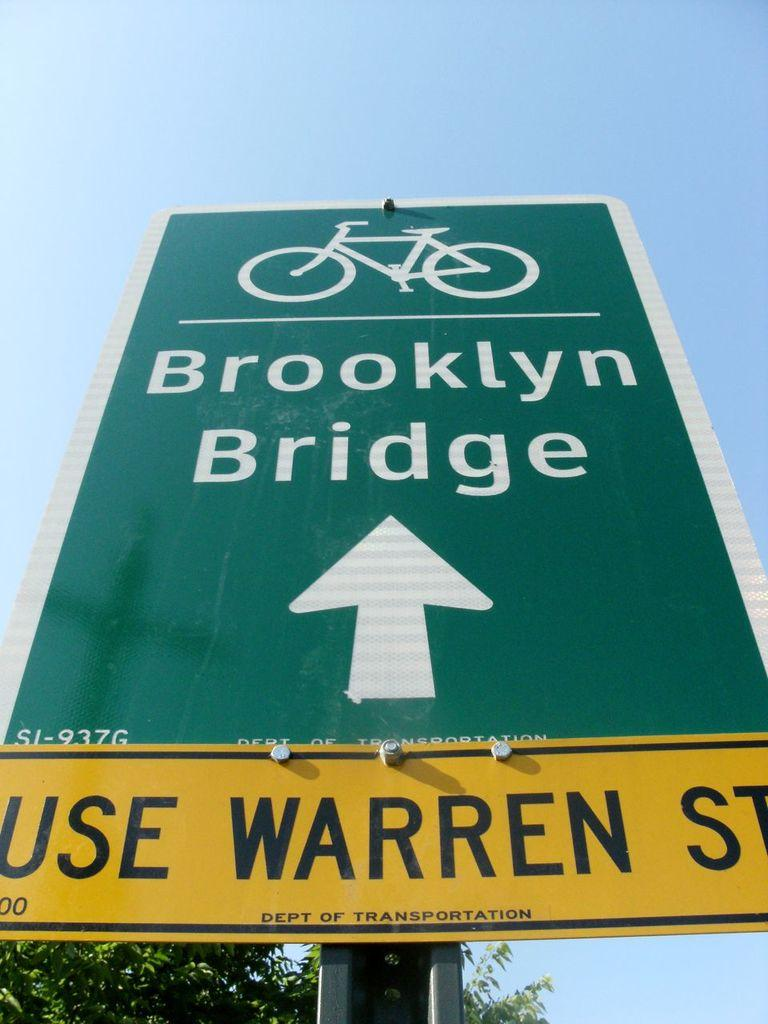<image>
Relay a brief, clear account of the picture shown. A green sign for bicycles for the Brooklyn Bridge on top of a yellow sign that says Use Warren St. 